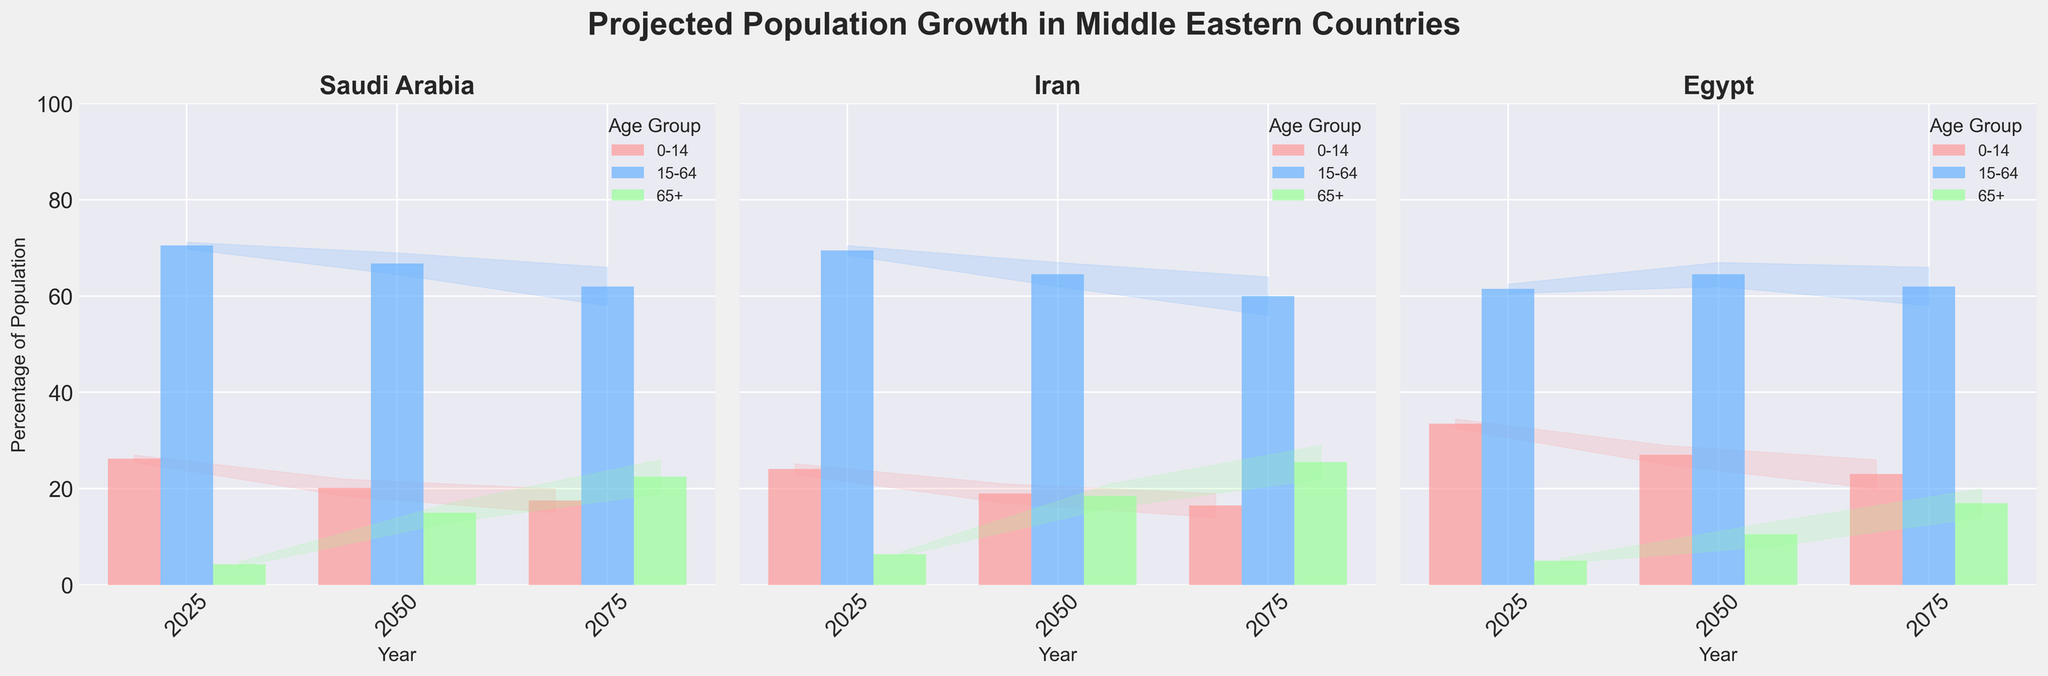What is the title of the plot? The title is prominently displayed at the top of the figure. It is "Projected Population Growth in Middle Eastern Countries".
Answer: Projected Population Growth in Middle Eastern Countries Which country has the highest projected percentage of the population aged 65+ in 2075? Look at the data for the year 2075 and the age group 65+ across all three countries. Iran's highest estimate is 29.0%, which is higher than Saudi Arabia's 26.0% and Egypt's 20.0%.
Answer: Iran How does the projected percentage of the 0-14 age group in Egypt in 2050 compare to that in 2075? Find the medium estimates for the 0-14 age group in Egypt for 2050 and 2075. In 2050, it is 27.0%, and in 2075, it is 23.0%. The percentage decreases by 4.0%.
Answer: It decreases by 4.0% What is the projected median population percentage of the 15-64 age group for Saudi Arabia in 2050 and 2075? Look at the medium estimates for the 15-64 age group in Saudi Arabia for the years 2050 and 2075. Add the estimates (66.8% + 62.0%) and divide by 2 to find the median. (66.8 + 62.0) / 2 = 64.4%.
Answer: 64.4% Between Iran and Saudi Arabia, which country has a higher projected population percentage of the 15-64 age group in 2025? Compare the medium estimates for the 15-64 age group for Iran and Saudi Arabia in 2025. Iran is at 69.5%, and Saudi Arabia is at 70.5%. Saudi Arabia has a higher projected percentage.
Answer: Saudi Arabia Which age group is projected to have the smallest population percentage in Egypt in 2025? Look at the medium estimates for the three age groups in Egypt in 2025. The percentages are: 0-14 (33.5%), 15-64 (61.5%), and 65+ (5.0%). The 65+ age group has the smallest percentage.
Answer: 65+ What is the overall trend for the 0-14 age group in Saudi Arabia from 2025 to 2075? Examine the values for the 0-14 age group in Saudi Arabia over the years 2025, 2050, and 2075. The medium estimates are 26.2% (2025), 20.2% (2050), and 17.5% (2075). The trend shows a decreasing percentage over time.
Answer: Decreasing By how much is the percentage of the population aged 65+ projected to increase in Iran from 2025 to 2075? Look at the medium estimates for the 65+ age group in Iran in 2025 and 2075. The values are 6.4% (2025) and 25.5% (2075). Subtract 6.4 from 25.5 to find the increase. 25.5 - 6.4 = 19.1%.
Answer: 19.1% Is the projected percentage of the 15-64 age group in 2050 higher in Egypt or Iran? Find the medium estimates for the 15-64 age group in 2050 for both Egypt and Iran. Egypt is at 64.5%, and Iran is at 64.5%. Both values are equal.
Answer: Equal In 2075, which country has the smallest range of projected population percentages for the 15-64 age group? For each country in 2075, calculate the range by subtracting the low estimate from the high estimate for the 15-64 age group. For Saudi Arabia: 66.0 - 58.0 = 8.0, Iran: 64.0 - 56.0 = 8.0, Egypt: 66.0 - 58.0 = 8.0. All ranges are the same: 8.0%.
Answer: All equal 